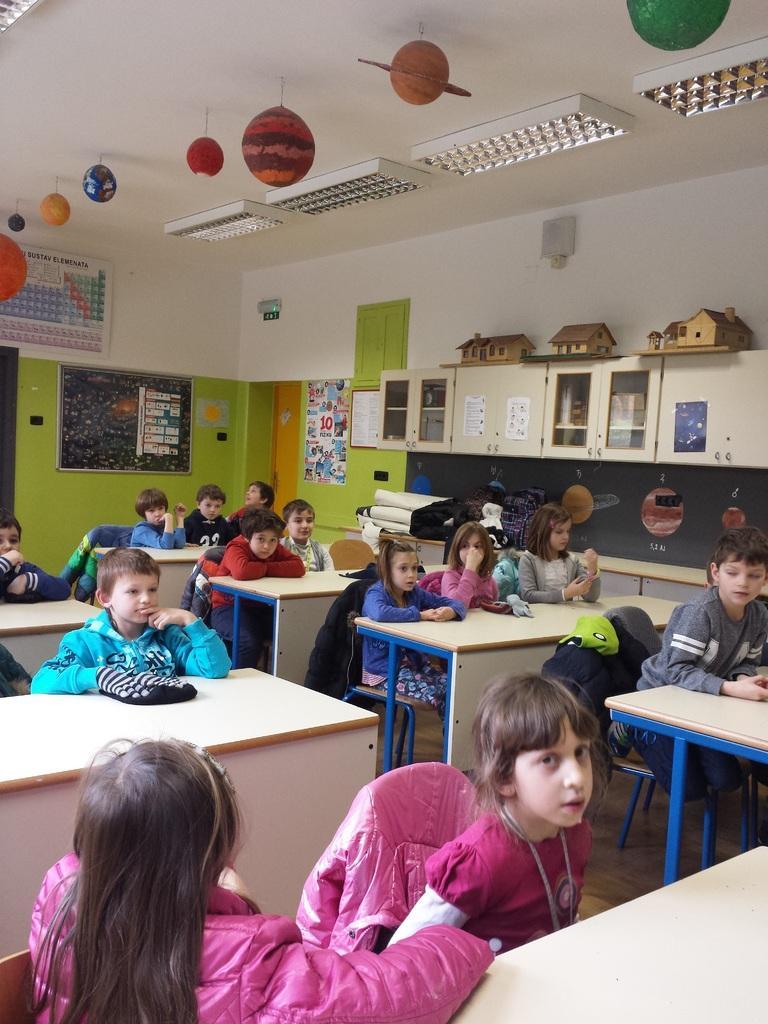How would you summarize this image in a sentence or two? This is a class room in which kids are sitting on the chair at the table. In the background we can see cupboards,posters on the wall. On the roof top we can see lights. 